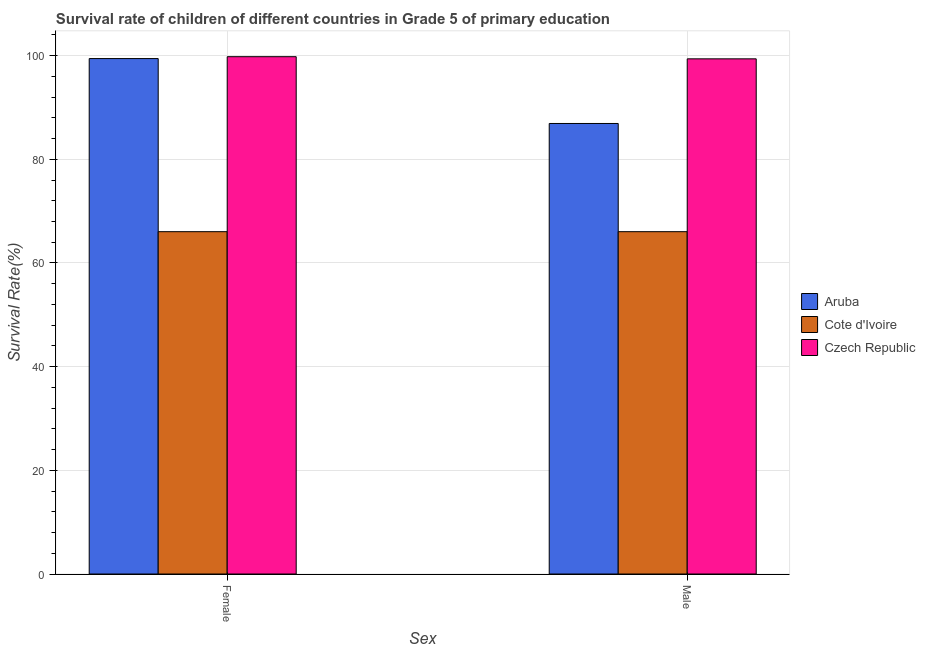How many bars are there on the 1st tick from the right?
Provide a succinct answer. 3. What is the survival rate of male students in primary education in Czech Republic?
Your answer should be compact. 99.38. Across all countries, what is the maximum survival rate of female students in primary education?
Provide a short and direct response. 99.8. Across all countries, what is the minimum survival rate of female students in primary education?
Your answer should be very brief. 66.04. In which country was the survival rate of female students in primary education maximum?
Keep it short and to the point. Czech Republic. In which country was the survival rate of male students in primary education minimum?
Offer a terse response. Cote d'Ivoire. What is the total survival rate of male students in primary education in the graph?
Offer a very short reply. 252.34. What is the difference between the survival rate of male students in primary education in Czech Republic and that in Aruba?
Offer a terse response. 12.47. What is the difference between the survival rate of female students in primary education in Aruba and the survival rate of male students in primary education in Czech Republic?
Ensure brevity in your answer.  0.05. What is the average survival rate of male students in primary education per country?
Provide a succinct answer. 84.11. What is the difference between the survival rate of female students in primary education and survival rate of male students in primary education in Aruba?
Provide a short and direct response. 12.52. In how many countries, is the survival rate of female students in primary education greater than 64 %?
Your answer should be very brief. 3. What is the ratio of the survival rate of female students in primary education in Aruba to that in Cote d'Ivoire?
Make the answer very short. 1.51. In how many countries, is the survival rate of female students in primary education greater than the average survival rate of female students in primary education taken over all countries?
Offer a very short reply. 2. What does the 1st bar from the left in Female represents?
Provide a succinct answer. Aruba. What does the 2nd bar from the right in Male represents?
Your answer should be compact. Cote d'Ivoire. How many countries are there in the graph?
Your answer should be very brief. 3. Does the graph contain any zero values?
Ensure brevity in your answer.  No. How many legend labels are there?
Give a very brief answer. 3. What is the title of the graph?
Provide a succinct answer. Survival rate of children of different countries in Grade 5 of primary education. What is the label or title of the X-axis?
Your answer should be very brief. Sex. What is the label or title of the Y-axis?
Offer a terse response. Survival Rate(%). What is the Survival Rate(%) in Aruba in Female?
Provide a succinct answer. 99.44. What is the Survival Rate(%) of Cote d'Ivoire in Female?
Give a very brief answer. 66.04. What is the Survival Rate(%) of Czech Republic in Female?
Your response must be concise. 99.8. What is the Survival Rate(%) in Aruba in Male?
Your response must be concise. 86.91. What is the Survival Rate(%) of Cote d'Ivoire in Male?
Provide a short and direct response. 66.04. What is the Survival Rate(%) of Czech Republic in Male?
Make the answer very short. 99.38. Across all Sex, what is the maximum Survival Rate(%) in Aruba?
Provide a succinct answer. 99.44. Across all Sex, what is the maximum Survival Rate(%) of Cote d'Ivoire?
Provide a succinct answer. 66.04. Across all Sex, what is the maximum Survival Rate(%) of Czech Republic?
Provide a short and direct response. 99.8. Across all Sex, what is the minimum Survival Rate(%) of Aruba?
Keep it short and to the point. 86.91. Across all Sex, what is the minimum Survival Rate(%) in Cote d'Ivoire?
Keep it short and to the point. 66.04. Across all Sex, what is the minimum Survival Rate(%) in Czech Republic?
Provide a succinct answer. 99.38. What is the total Survival Rate(%) in Aruba in the graph?
Your answer should be compact. 186.35. What is the total Survival Rate(%) in Cote d'Ivoire in the graph?
Your answer should be compact. 132.08. What is the total Survival Rate(%) of Czech Republic in the graph?
Your answer should be very brief. 199.18. What is the difference between the Survival Rate(%) in Aruba in Female and that in Male?
Keep it short and to the point. 12.52. What is the difference between the Survival Rate(%) in Cote d'Ivoire in Female and that in Male?
Give a very brief answer. -0. What is the difference between the Survival Rate(%) of Czech Republic in Female and that in Male?
Offer a terse response. 0.41. What is the difference between the Survival Rate(%) in Aruba in Female and the Survival Rate(%) in Cote d'Ivoire in Male?
Offer a very short reply. 33.39. What is the difference between the Survival Rate(%) in Aruba in Female and the Survival Rate(%) in Czech Republic in Male?
Keep it short and to the point. 0.05. What is the difference between the Survival Rate(%) in Cote d'Ivoire in Female and the Survival Rate(%) in Czech Republic in Male?
Your answer should be very brief. -33.34. What is the average Survival Rate(%) of Aruba per Sex?
Keep it short and to the point. 93.17. What is the average Survival Rate(%) of Cote d'Ivoire per Sex?
Make the answer very short. 66.04. What is the average Survival Rate(%) in Czech Republic per Sex?
Make the answer very short. 99.59. What is the difference between the Survival Rate(%) in Aruba and Survival Rate(%) in Cote d'Ivoire in Female?
Your answer should be very brief. 33.4. What is the difference between the Survival Rate(%) of Aruba and Survival Rate(%) of Czech Republic in Female?
Give a very brief answer. -0.36. What is the difference between the Survival Rate(%) of Cote d'Ivoire and Survival Rate(%) of Czech Republic in Female?
Offer a very short reply. -33.76. What is the difference between the Survival Rate(%) in Aruba and Survival Rate(%) in Cote d'Ivoire in Male?
Offer a terse response. 20.87. What is the difference between the Survival Rate(%) in Aruba and Survival Rate(%) in Czech Republic in Male?
Give a very brief answer. -12.47. What is the difference between the Survival Rate(%) in Cote d'Ivoire and Survival Rate(%) in Czech Republic in Male?
Make the answer very short. -33.34. What is the ratio of the Survival Rate(%) of Aruba in Female to that in Male?
Provide a short and direct response. 1.14. What is the ratio of the Survival Rate(%) of Czech Republic in Female to that in Male?
Your answer should be very brief. 1. What is the difference between the highest and the second highest Survival Rate(%) of Aruba?
Keep it short and to the point. 12.52. What is the difference between the highest and the second highest Survival Rate(%) of Cote d'Ivoire?
Keep it short and to the point. 0. What is the difference between the highest and the second highest Survival Rate(%) of Czech Republic?
Provide a succinct answer. 0.41. What is the difference between the highest and the lowest Survival Rate(%) of Aruba?
Give a very brief answer. 12.52. What is the difference between the highest and the lowest Survival Rate(%) of Cote d'Ivoire?
Make the answer very short. 0. What is the difference between the highest and the lowest Survival Rate(%) of Czech Republic?
Give a very brief answer. 0.41. 